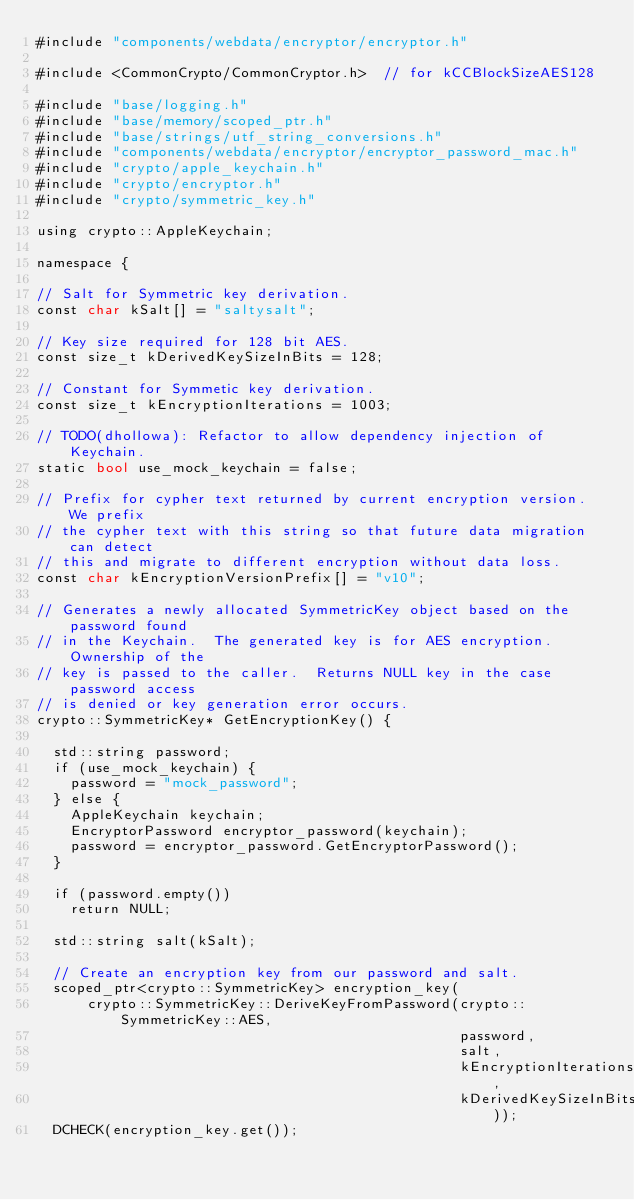Convert code to text. <code><loc_0><loc_0><loc_500><loc_500><_ObjectiveC_>#include "components/webdata/encryptor/encryptor.h"

#include <CommonCrypto/CommonCryptor.h>  // for kCCBlockSizeAES128

#include "base/logging.h"
#include "base/memory/scoped_ptr.h"
#include "base/strings/utf_string_conversions.h"
#include "components/webdata/encryptor/encryptor_password_mac.h"
#include "crypto/apple_keychain.h"
#include "crypto/encryptor.h"
#include "crypto/symmetric_key.h"

using crypto::AppleKeychain;

namespace {

// Salt for Symmetric key derivation.
const char kSalt[] = "saltysalt";

// Key size required for 128 bit AES.
const size_t kDerivedKeySizeInBits = 128;

// Constant for Symmetic key derivation.
const size_t kEncryptionIterations = 1003;

// TODO(dhollowa): Refactor to allow dependency injection of Keychain.
static bool use_mock_keychain = false;

// Prefix for cypher text returned by current encryption version.  We prefix
// the cypher text with this string so that future data migration can detect
// this and migrate to different encryption without data loss.
const char kEncryptionVersionPrefix[] = "v10";

// Generates a newly allocated SymmetricKey object based on the password found
// in the Keychain.  The generated key is for AES encryption.  Ownership of the
// key is passed to the caller.  Returns NULL key in the case password access
// is denied or key generation error occurs.
crypto::SymmetricKey* GetEncryptionKey() {

  std::string password;
  if (use_mock_keychain) {
    password = "mock_password";
  } else {
    AppleKeychain keychain;
    EncryptorPassword encryptor_password(keychain);
    password = encryptor_password.GetEncryptorPassword();
  }

  if (password.empty())
    return NULL;

  std::string salt(kSalt);

  // Create an encryption key from our password and salt.
  scoped_ptr<crypto::SymmetricKey> encryption_key(
      crypto::SymmetricKey::DeriveKeyFromPassword(crypto::SymmetricKey::AES,
                                                  password,
                                                  salt,
                                                  kEncryptionIterations,
                                                  kDerivedKeySizeInBits));
  DCHECK(encryption_key.get());
</code> 